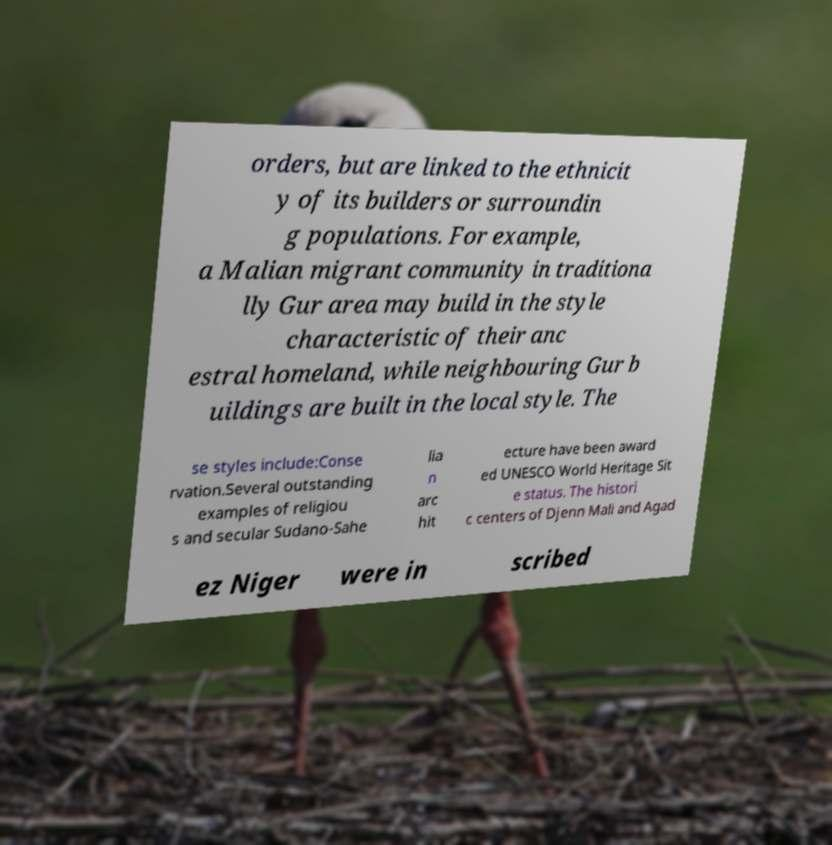Could you assist in decoding the text presented in this image and type it out clearly? orders, but are linked to the ethnicit y of its builders or surroundin g populations. For example, a Malian migrant community in traditiona lly Gur area may build in the style characteristic of their anc estral homeland, while neighbouring Gur b uildings are built in the local style. The se styles include:Conse rvation.Several outstanding examples of religiou s and secular Sudano-Sahe lia n arc hit ecture have been award ed UNESCO World Heritage Sit e status. The histori c centers of Djenn Mali and Agad ez Niger were in scribed 